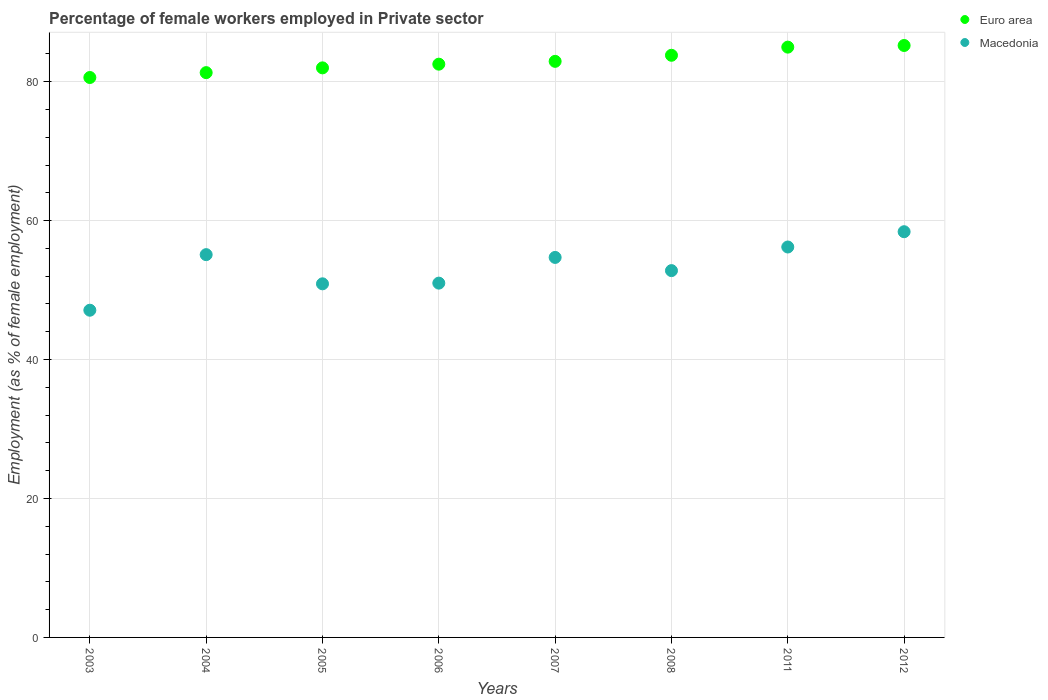Is the number of dotlines equal to the number of legend labels?
Offer a very short reply. Yes. What is the percentage of females employed in Private sector in Macedonia in 2012?
Keep it short and to the point. 58.4. Across all years, what is the maximum percentage of females employed in Private sector in Macedonia?
Your answer should be compact. 58.4. Across all years, what is the minimum percentage of females employed in Private sector in Euro area?
Make the answer very short. 80.6. What is the total percentage of females employed in Private sector in Macedonia in the graph?
Offer a terse response. 426.2. What is the difference between the percentage of females employed in Private sector in Macedonia in 2008 and that in 2011?
Give a very brief answer. -3.4. What is the difference between the percentage of females employed in Private sector in Euro area in 2005 and the percentage of females employed in Private sector in Macedonia in 2012?
Make the answer very short. 23.59. What is the average percentage of females employed in Private sector in Euro area per year?
Your response must be concise. 82.91. In the year 2004, what is the difference between the percentage of females employed in Private sector in Euro area and percentage of females employed in Private sector in Macedonia?
Your answer should be compact. 26.2. What is the ratio of the percentage of females employed in Private sector in Euro area in 2004 to that in 2008?
Provide a succinct answer. 0.97. Is the percentage of females employed in Private sector in Euro area in 2005 less than that in 2012?
Offer a very short reply. Yes. What is the difference between the highest and the second highest percentage of females employed in Private sector in Euro area?
Your answer should be very brief. 0.24. What is the difference between the highest and the lowest percentage of females employed in Private sector in Macedonia?
Ensure brevity in your answer.  11.3. Does the percentage of females employed in Private sector in Macedonia monotonically increase over the years?
Your answer should be compact. No. Is the percentage of females employed in Private sector in Macedonia strictly less than the percentage of females employed in Private sector in Euro area over the years?
Provide a succinct answer. Yes. How many dotlines are there?
Make the answer very short. 2. How many years are there in the graph?
Your answer should be compact. 8. Does the graph contain grids?
Your response must be concise. Yes. How many legend labels are there?
Provide a succinct answer. 2. How are the legend labels stacked?
Make the answer very short. Vertical. What is the title of the graph?
Offer a very short reply. Percentage of female workers employed in Private sector. What is the label or title of the Y-axis?
Your answer should be compact. Employment (as % of female employment). What is the Employment (as % of female employment) of Euro area in 2003?
Make the answer very short. 80.6. What is the Employment (as % of female employment) of Macedonia in 2003?
Give a very brief answer. 47.1. What is the Employment (as % of female employment) of Euro area in 2004?
Provide a succinct answer. 81.3. What is the Employment (as % of female employment) of Macedonia in 2004?
Keep it short and to the point. 55.1. What is the Employment (as % of female employment) in Euro area in 2005?
Keep it short and to the point. 81.99. What is the Employment (as % of female employment) of Macedonia in 2005?
Make the answer very short. 50.9. What is the Employment (as % of female employment) in Euro area in 2006?
Offer a very short reply. 82.52. What is the Employment (as % of female employment) in Euro area in 2007?
Offer a terse response. 82.92. What is the Employment (as % of female employment) in Macedonia in 2007?
Your response must be concise. 54.7. What is the Employment (as % of female employment) in Euro area in 2008?
Provide a succinct answer. 83.8. What is the Employment (as % of female employment) of Macedonia in 2008?
Offer a very short reply. 52.8. What is the Employment (as % of female employment) of Euro area in 2011?
Provide a short and direct response. 84.97. What is the Employment (as % of female employment) of Macedonia in 2011?
Offer a very short reply. 56.2. What is the Employment (as % of female employment) of Euro area in 2012?
Your answer should be very brief. 85.21. What is the Employment (as % of female employment) in Macedonia in 2012?
Your answer should be compact. 58.4. Across all years, what is the maximum Employment (as % of female employment) of Euro area?
Ensure brevity in your answer.  85.21. Across all years, what is the maximum Employment (as % of female employment) of Macedonia?
Your response must be concise. 58.4. Across all years, what is the minimum Employment (as % of female employment) of Euro area?
Offer a terse response. 80.6. Across all years, what is the minimum Employment (as % of female employment) in Macedonia?
Make the answer very short. 47.1. What is the total Employment (as % of female employment) in Euro area in the graph?
Provide a short and direct response. 663.3. What is the total Employment (as % of female employment) in Macedonia in the graph?
Your response must be concise. 426.2. What is the difference between the Employment (as % of female employment) of Euro area in 2003 and that in 2004?
Offer a very short reply. -0.7. What is the difference between the Employment (as % of female employment) of Euro area in 2003 and that in 2005?
Provide a short and direct response. -1.39. What is the difference between the Employment (as % of female employment) of Euro area in 2003 and that in 2006?
Your response must be concise. -1.92. What is the difference between the Employment (as % of female employment) of Macedonia in 2003 and that in 2006?
Your response must be concise. -3.9. What is the difference between the Employment (as % of female employment) in Euro area in 2003 and that in 2007?
Keep it short and to the point. -2.33. What is the difference between the Employment (as % of female employment) of Euro area in 2003 and that in 2008?
Offer a very short reply. -3.2. What is the difference between the Employment (as % of female employment) in Euro area in 2003 and that in 2011?
Offer a terse response. -4.37. What is the difference between the Employment (as % of female employment) of Macedonia in 2003 and that in 2011?
Provide a succinct answer. -9.1. What is the difference between the Employment (as % of female employment) in Euro area in 2003 and that in 2012?
Offer a terse response. -4.61. What is the difference between the Employment (as % of female employment) of Macedonia in 2003 and that in 2012?
Provide a short and direct response. -11.3. What is the difference between the Employment (as % of female employment) of Euro area in 2004 and that in 2005?
Provide a short and direct response. -0.69. What is the difference between the Employment (as % of female employment) of Euro area in 2004 and that in 2006?
Provide a succinct answer. -1.22. What is the difference between the Employment (as % of female employment) in Euro area in 2004 and that in 2007?
Provide a succinct answer. -1.63. What is the difference between the Employment (as % of female employment) in Euro area in 2004 and that in 2008?
Your answer should be compact. -2.5. What is the difference between the Employment (as % of female employment) in Macedonia in 2004 and that in 2008?
Your answer should be very brief. 2.3. What is the difference between the Employment (as % of female employment) of Euro area in 2004 and that in 2011?
Make the answer very short. -3.67. What is the difference between the Employment (as % of female employment) of Macedonia in 2004 and that in 2011?
Make the answer very short. -1.1. What is the difference between the Employment (as % of female employment) in Euro area in 2004 and that in 2012?
Make the answer very short. -3.91. What is the difference between the Employment (as % of female employment) of Euro area in 2005 and that in 2006?
Provide a succinct answer. -0.53. What is the difference between the Employment (as % of female employment) of Euro area in 2005 and that in 2007?
Your answer should be compact. -0.94. What is the difference between the Employment (as % of female employment) in Macedonia in 2005 and that in 2007?
Provide a short and direct response. -3.8. What is the difference between the Employment (as % of female employment) of Euro area in 2005 and that in 2008?
Your answer should be compact. -1.81. What is the difference between the Employment (as % of female employment) in Euro area in 2005 and that in 2011?
Make the answer very short. -2.98. What is the difference between the Employment (as % of female employment) in Euro area in 2005 and that in 2012?
Give a very brief answer. -3.22. What is the difference between the Employment (as % of female employment) of Macedonia in 2005 and that in 2012?
Provide a succinct answer. -7.5. What is the difference between the Employment (as % of female employment) in Euro area in 2006 and that in 2007?
Your answer should be compact. -0.41. What is the difference between the Employment (as % of female employment) in Euro area in 2006 and that in 2008?
Ensure brevity in your answer.  -1.28. What is the difference between the Employment (as % of female employment) in Euro area in 2006 and that in 2011?
Offer a terse response. -2.45. What is the difference between the Employment (as % of female employment) in Macedonia in 2006 and that in 2011?
Offer a terse response. -5.2. What is the difference between the Employment (as % of female employment) in Euro area in 2006 and that in 2012?
Offer a very short reply. -2.69. What is the difference between the Employment (as % of female employment) in Macedonia in 2006 and that in 2012?
Provide a succinct answer. -7.4. What is the difference between the Employment (as % of female employment) of Euro area in 2007 and that in 2008?
Your answer should be very brief. -0.87. What is the difference between the Employment (as % of female employment) in Macedonia in 2007 and that in 2008?
Offer a very short reply. 1.9. What is the difference between the Employment (as % of female employment) in Euro area in 2007 and that in 2011?
Offer a very short reply. -2.05. What is the difference between the Employment (as % of female employment) of Euro area in 2007 and that in 2012?
Give a very brief answer. -2.28. What is the difference between the Employment (as % of female employment) in Euro area in 2008 and that in 2011?
Give a very brief answer. -1.17. What is the difference between the Employment (as % of female employment) in Macedonia in 2008 and that in 2011?
Offer a very short reply. -3.4. What is the difference between the Employment (as % of female employment) in Euro area in 2008 and that in 2012?
Provide a short and direct response. -1.41. What is the difference between the Employment (as % of female employment) of Macedonia in 2008 and that in 2012?
Your response must be concise. -5.6. What is the difference between the Employment (as % of female employment) in Euro area in 2011 and that in 2012?
Provide a short and direct response. -0.24. What is the difference between the Employment (as % of female employment) in Macedonia in 2011 and that in 2012?
Keep it short and to the point. -2.2. What is the difference between the Employment (as % of female employment) in Euro area in 2003 and the Employment (as % of female employment) in Macedonia in 2004?
Offer a very short reply. 25.5. What is the difference between the Employment (as % of female employment) of Euro area in 2003 and the Employment (as % of female employment) of Macedonia in 2005?
Give a very brief answer. 29.7. What is the difference between the Employment (as % of female employment) in Euro area in 2003 and the Employment (as % of female employment) in Macedonia in 2006?
Make the answer very short. 29.6. What is the difference between the Employment (as % of female employment) in Euro area in 2003 and the Employment (as % of female employment) in Macedonia in 2007?
Offer a terse response. 25.9. What is the difference between the Employment (as % of female employment) of Euro area in 2003 and the Employment (as % of female employment) of Macedonia in 2008?
Offer a terse response. 27.8. What is the difference between the Employment (as % of female employment) of Euro area in 2003 and the Employment (as % of female employment) of Macedonia in 2011?
Provide a succinct answer. 24.4. What is the difference between the Employment (as % of female employment) of Euro area in 2003 and the Employment (as % of female employment) of Macedonia in 2012?
Offer a very short reply. 22.2. What is the difference between the Employment (as % of female employment) in Euro area in 2004 and the Employment (as % of female employment) in Macedonia in 2005?
Provide a succinct answer. 30.4. What is the difference between the Employment (as % of female employment) of Euro area in 2004 and the Employment (as % of female employment) of Macedonia in 2006?
Provide a short and direct response. 30.3. What is the difference between the Employment (as % of female employment) in Euro area in 2004 and the Employment (as % of female employment) in Macedonia in 2007?
Your answer should be compact. 26.6. What is the difference between the Employment (as % of female employment) in Euro area in 2004 and the Employment (as % of female employment) in Macedonia in 2008?
Provide a succinct answer. 28.5. What is the difference between the Employment (as % of female employment) of Euro area in 2004 and the Employment (as % of female employment) of Macedonia in 2011?
Offer a very short reply. 25.1. What is the difference between the Employment (as % of female employment) in Euro area in 2004 and the Employment (as % of female employment) in Macedonia in 2012?
Make the answer very short. 22.9. What is the difference between the Employment (as % of female employment) of Euro area in 2005 and the Employment (as % of female employment) of Macedonia in 2006?
Keep it short and to the point. 30.99. What is the difference between the Employment (as % of female employment) in Euro area in 2005 and the Employment (as % of female employment) in Macedonia in 2007?
Provide a succinct answer. 27.29. What is the difference between the Employment (as % of female employment) in Euro area in 2005 and the Employment (as % of female employment) in Macedonia in 2008?
Keep it short and to the point. 29.19. What is the difference between the Employment (as % of female employment) in Euro area in 2005 and the Employment (as % of female employment) in Macedonia in 2011?
Provide a short and direct response. 25.79. What is the difference between the Employment (as % of female employment) in Euro area in 2005 and the Employment (as % of female employment) in Macedonia in 2012?
Offer a very short reply. 23.59. What is the difference between the Employment (as % of female employment) of Euro area in 2006 and the Employment (as % of female employment) of Macedonia in 2007?
Your response must be concise. 27.82. What is the difference between the Employment (as % of female employment) in Euro area in 2006 and the Employment (as % of female employment) in Macedonia in 2008?
Offer a very short reply. 29.72. What is the difference between the Employment (as % of female employment) in Euro area in 2006 and the Employment (as % of female employment) in Macedonia in 2011?
Your answer should be compact. 26.32. What is the difference between the Employment (as % of female employment) of Euro area in 2006 and the Employment (as % of female employment) of Macedonia in 2012?
Offer a very short reply. 24.12. What is the difference between the Employment (as % of female employment) of Euro area in 2007 and the Employment (as % of female employment) of Macedonia in 2008?
Offer a very short reply. 30.12. What is the difference between the Employment (as % of female employment) of Euro area in 2007 and the Employment (as % of female employment) of Macedonia in 2011?
Ensure brevity in your answer.  26.72. What is the difference between the Employment (as % of female employment) in Euro area in 2007 and the Employment (as % of female employment) in Macedonia in 2012?
Provide a succinct answer. 24.52. What is the difference between the Employment (as % of female employment) of Euro area in 2008 and the Employment (as % of female employment) of Macedonia in 2011?
Give a very brief answer. 27.6. What is the difference between the Employment (as % of female employment) in Euro area in 2008 and the Employment (as % of female employment) in Macedonia in 2012?
Give a very brief answer. 25.4. What is the difference between the Employment (as % of female employment) of Euro area in 2011 and the Employment (as % of female employment) of Macedonia in 2012?
Give a very brief answer. 26.57. What is the average Employment (as % of female employment) of Euro area per year?
Make the answer very short. 82.91. What is the average Employment (as % of female employment) in Macedonia per year?
Offer a very short reply. 53.27. In the year 2003, what is the difference between the Employment (as % of female employment) of Euro area and Employment (as % of female employment) of Macedonia?
Your answer should be very brief. 33.5. In the year 2004, what is the difference between the Employment (as % of female employment) of Euro area and Employment (as % of female employment) of Macedonia?
Your answer should be very brief. 26.2. In the year 2005, what is the difference between the Employment (as % of female employment) in Euro area and Employment (as % of female employment) in Macedonia?
Offer a very short reply. 31.09. In the year 2006, what is the difference between the Employment (as % of female employment) of Euro area and Employment (as % of female employment) of Macedonia?
Provide a succinct answer. 31.52. In the year 2007, what is the difference between the Employment (as % of female employment) in Euro area and Employment (as % of female employment) in Macedonia?
Make the answer very short. 28.22. In the year 2008, what is the difference between the Employment (as % of female employment) in Euro area and Employment (as % of female employment) in Macedonia?
Keep it short and to the point. 31. In the year 2011, what is the difference between the Employment (as % of female employment) in Euro area and Employment (as % of female employment) in Macedonia?
Give a very brief answer. 28.77. In the year 2012, what is the difference between the Employment (as % of female employment) in Euro area and Employment (as % of female employment) in Macedonia?
Your answer should be very brief. 26.81. What is the ratio of the Employment (as % of female employment) in Euro area in 2003 to that in 2004?
Offer a very short reply. 0.99. What is the ratio of the Employment (as % of female employment) of Macedonia in 2003 to that in 2004?
Ensure brevity in your answer.  0.85. What is the ratio of the Employment (as % of female employment) of Euro area in 2003 to that in 2005?
Offer a very short reply. 0.98. What is the ratio of the Employment (as % of female employment) of Macedonia in 2003 to that in 2005?
Provide a succinct answer. 0.93. What is the ratio of the Employment (as % of female employment) of Euro area in 2003 to that in 2006?
Ensure brevity in your answer.  0.98. What is the ratio of the Employment (as % of female employment) of Macedonia in 2003 to that in 2006?
Offer a terse response. 0.92. What is the ratio of the Employment (as % of female employment) of Euro area in 2003 to that in 2007?
Your answer should be compact. 0.97. What is the ratio of the Employment (as % of female employment) in Macedonia in 2003 to that in 2007?
Make the answer very short. 0.86. What is the ratio of the Employment (as % of female employment) in Euro area in 2003 to that in 2008?
Provide a short and direct response. 0.96. What is the ratio of the Employment (as % of female employment) in Macedonia in 2003 to that in 2008?
Your answer should be compact. 0.89. What is the ratio of the Employment (as % of female employment) of Euro area in 2003 to that in 2011?
Provide a short and direct response. 0.95. What is the ratio of the Employment (as % of female employment) of Macedonia in 2003 to that in 2011?
Your answer should be compact. 0.84. What is the ratio of the Employment (as % of female employment) of Euro area in 2003 to that in 2012?
Keep it short and to the point. 0.95. What is the ratio of the Employment (as % of female employment) in Macedonia in 2003 to that in 2012?
Give a very brief answer. 0.81. What is the ratio of the Employment (as % of female employment) of Macedonia in 2004 to that in 2005?
Ensure brevity in your answer.  1.08. What is the ratio of the Employment (as % of female employment) in Euro area in 2004 to that in 2006?
Your answer should be compact. 0.99. What is the ratio of the Employment (as % of female employment) of Macedonia in 2004 to that in 2006?
Your response must be concise. 1.08. What is the ratio of the Employment (as % of female employment) of Euro area in 2004 to that in 2007?
Your answer should be compact. 0.98. What is the ratio of the Employment (as % of female employment) of Macedonia in 2004 to that in 2007?
Ensure brevity in your answer.  1.01. What is the ratio of the Employment (as % of female employment) of Euro area in 2004 to that in 2008?
Offer a very short reply. 0.97. What is the ratio of the Employment (as % of female employment) in Macedonia in 2004 to that in 2008?
Provide a succinct answer. 1.04. What is the ratio of the Employment (as % of female employment) in Euro area in 2004 to that in 2011?
Your response must be concise. 0.96. What is the ratio of the Employment (as % of female employment) in Macedonia in 2004 to that in 2011?
Your response must be concise. 0.98. What is the ratio of the Employment (as % of female employment) in Euro area in 2004 to that in 2012?
Give a very brief answer. 0.95. What is the ratio of the Employment (as % of female employment) in Macedonia in 2004 to that in 2012?
Your answer should be compact. 0.94. What is the ratio of the Employment (as % of female employment) in Macedonia in 2005 to that in 2006?
Your answer should be very brief. 1. What is the ratio of the Employment (as % of female employment) in Euro area in 2005 to that in 2007?
Offer a terse response. 0.99. What is the ratio of the Employment (as % of female employment) in Macedonia in 2005 to that in 2007?
Ensure brevity in your answer.  0.93. What is the ratio of the Employment (as % of female employment) of Euro area in 2005 to that in 2008?
Give a very brief answer. 0.98. What is the ratio of the Employment (as % of female employment) of Euro area in 2005 to that in 2011?
Give a very brief answer. 0.96. What is the ratio of the Employment (as % of female employment) in Macedonia in 2005 to that in 2011?
Provide a short and direct response. 0.91. What is the ratio of the Employment (as % of female employment) in Euro area in 2005 to that in 2012?
Provide a short and direct response. 0.96. What is the ratio of the Employment (as % of female employment) of Macedonia in 2005 to that in 2012?
Give a very brief answer. 0.87. What is the ratio of the Employment (as % of female employment) of Euro area in 2006 to that in 2007?
Offer a terse response. 1. What is the ratio of the Employment (as % of female employment) in Macedonia in 2006 to that in 2007?
Give a very brief answer. 0.93. What is the ratio of the Employment (as % of female employment) of Euro area in 2006 to that in 2008?
Provide a short and direct response. 0.98. What is the ratio of the Employment (as % of female employment) of Macedonia in 2006 to that in 2008?
Your answer should be compact. 0.97. What is the ratio of the Employment (as % of female employment) of Euro area in 2006 to that in 2011?
Your answer should be compact. 0.97. What is the ratio of the Employment (as % of female employment) in Macedonia in 2006 to that in 2011?
Ensure brevity in your answer.  0.91. What is the ratio of the Employment (as % of female employment) in Euro area in 2006 to that in 2012?
Provide a succinct answer. 0.97. What is the ratio of the Employment (as % of female employment) in Macedonia in 2006 to that in 2012?
Provide a succinct answer. 0.87. What is the ratio of the Employment (as % of female employment) of Macedonia in 2007 to that in 2008?
Your answer should be very brief. 1.04. What is the ratio of the Employment (as % of female employment) in Euro area in 2007 to that in 2011?
Give a very brief answer. 0.98. What is the ratio of the Employment (as % of female employment) of Macedonia in 2007 to that in 2011?
Give a very brief answer. 0.97. What is the ratio of the Employment (as % of female employment) of Euro area in 2007 to that in 2012?
Your response must be concise. 0.97. What is the ratio of the Employment (as % of female employment) in Macedonia in 2007 to that in 2012?
Your response must be concise. 0.94. What is the ratio of the Employment (as % of female employment) in Euro area in 2008 to that in 2011?
Provide a short and direct response. 0.99. What is the ratio of the Employment (as % of female employment) of Macedonia in 2008 to that in 2011?
Your response must be concise. 0.94. What is the ratio of the Employment (as % of female employment) of Euro area in 2008 to that in 2012?
Your answer should be compact. 0.98. What is the ratio of the Employment (as % of female employment) in Macedonia in 2008 to that in 2012?
Offer a terse response. 0.9. What is the ratio of the Employment (as % of female employment) of Euro area in 2011 to that in 2012?
Your answer should be compact. 1. What is the ratio of the Employment (as % of female employment) in Macedonia in 2011 to that in 2012?
Offer a terse response. 0.96. What is the difference between the highest and the second highest Employment (as % of female employment) in Euro area?
Make the answer very short. 0.24. What is the difference between the highest and the lowest Employment (as % of female employment) in Euro area?
Your answer should be very brief. 4.61. 